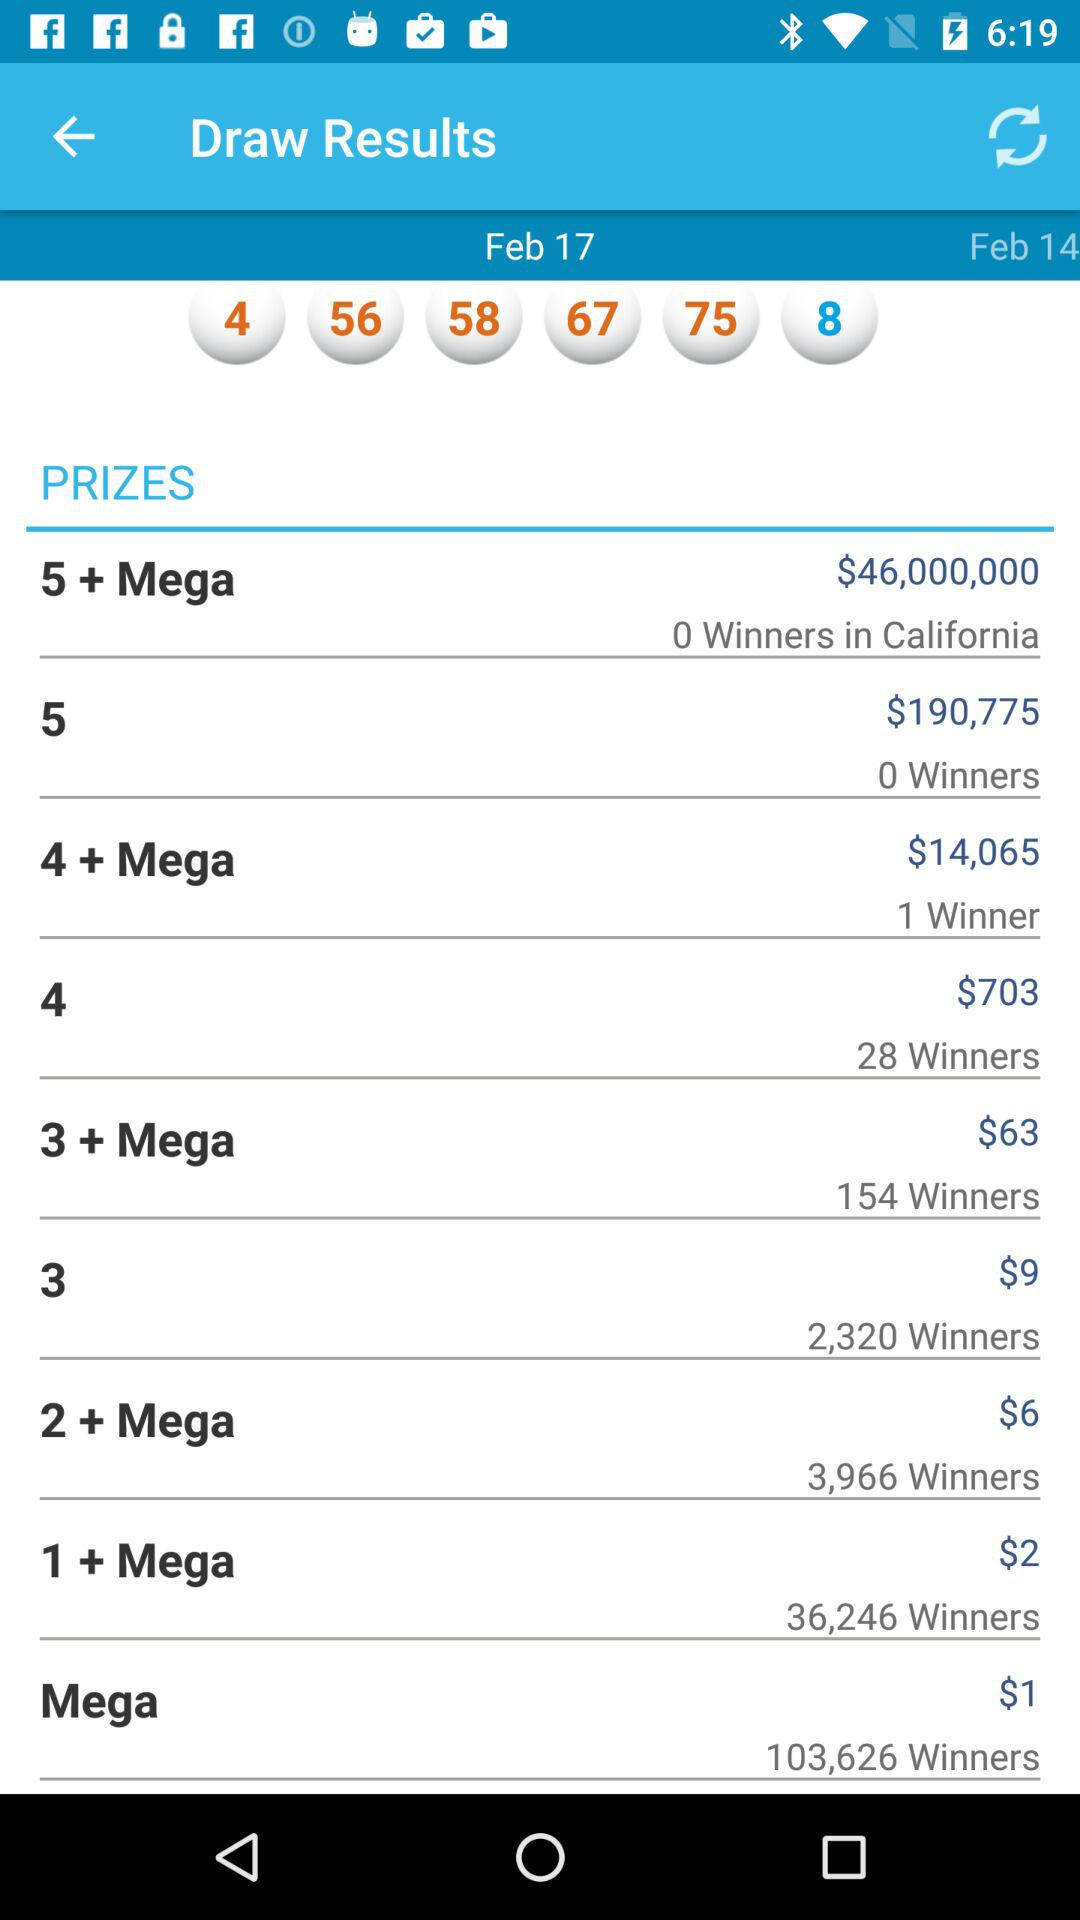How many winners are there in California? There are 0 winners in California. 